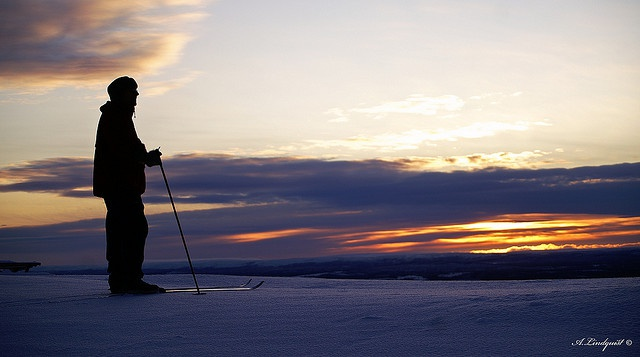Describe the objects in this image and their specific colors. I can see people in black, gray, navy, and ivory tones and skis in black, gray, navy, and darkgray tones in this image. 